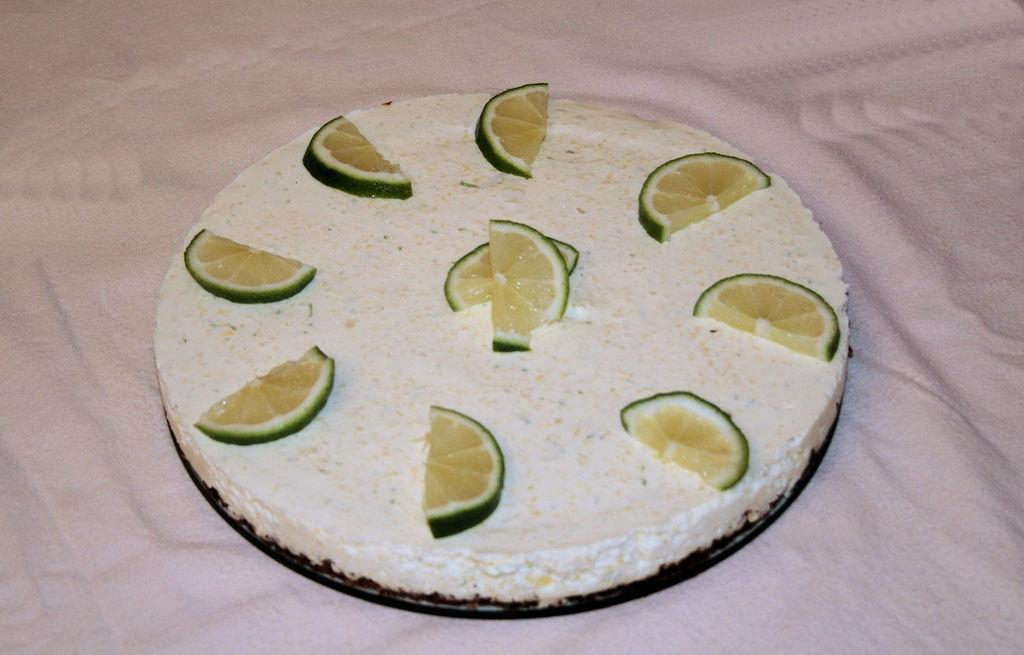What is the main subject of the image? There is a cake in the image. Where is the cake located? The cake is on a bed. What decorations are on the cake? There are orange pieces on the cake. What color is the bed sheet? The bed sheet is pink in color. What type of hair can be seen on the cake in the image? There is no hair present on the cake in the image. Can you tell me how many rakes are used to decorate the cake? There are no rakes present on the cake in the image. 